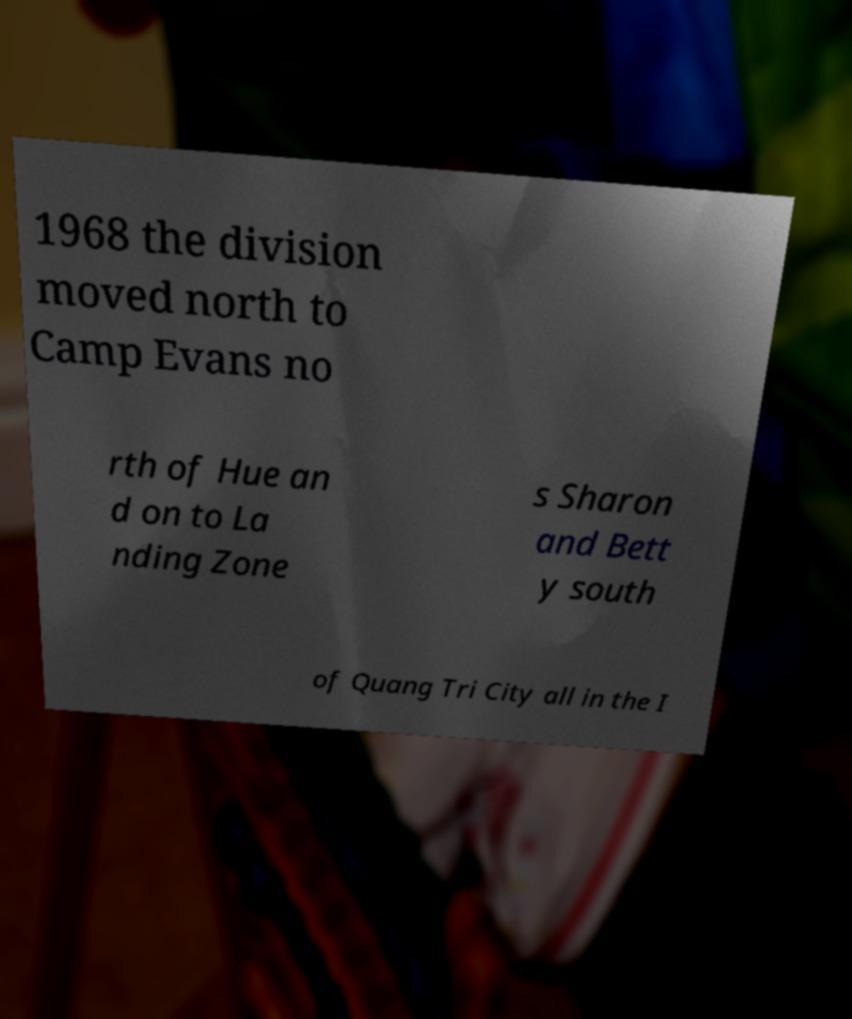Can you accurately transcribe the text from the provided image for me? 1968 the division moved north to Camp Evans no rth of Hue an d on to La nding Zone s Sharon and Bett y south of Quang Tri City all in the I 